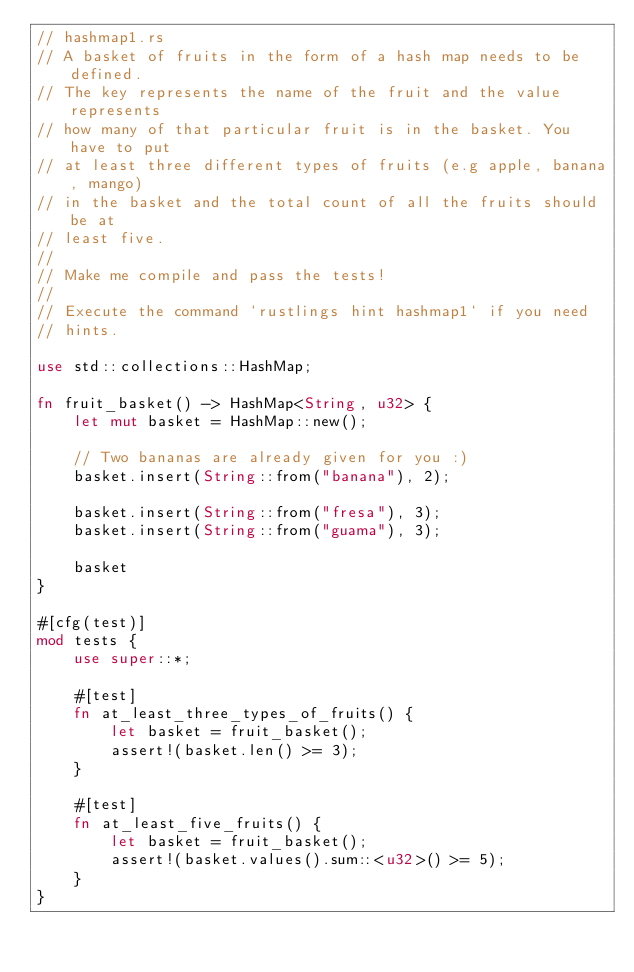<code> <loc_0><loc_0><loc_500><loc_500><_Rust_>// hashmap1.rs
// A basket of fruits in the form of a hash map needs to be defined.
// The key represents the name of the fruit and the value represents
// how many of that particular fruit is in the basket. You have to put
// at least three different types of fruits (e.g apple, banana, mango)
// in the basket and the total count of all the fruits should be at
// least five.
//
// Make me compile and pass the tests!
//
// Execute the command `rustlings hint hashmap1` if you need
// hints.

use std::collections::HashMap;

fn fruit_basket() -> HashMap<String, u32> {
    let mut basket = HashMap::new();

    // Two bananas are already given for you :)
    basket.insert(String::from("banana"), 2);

    basket.insert(String::from("fresa"), 3);
    basket.insert(String::from("guama"), 3);

    basket
}

#[cfg(test)]
mod tests {
    use super::*;

    #[test]
    fn at_least_three_types_of_fruits() {
        let basket = fruit_basket();
        assert!(basket.len() >= 3);
    }

    #[test]
    fn at_least_five_fruits() {
        let basket = fruit_basket();
        assert!(basket.values().sum::<u32>() >= 5);
    }
}
</code> 